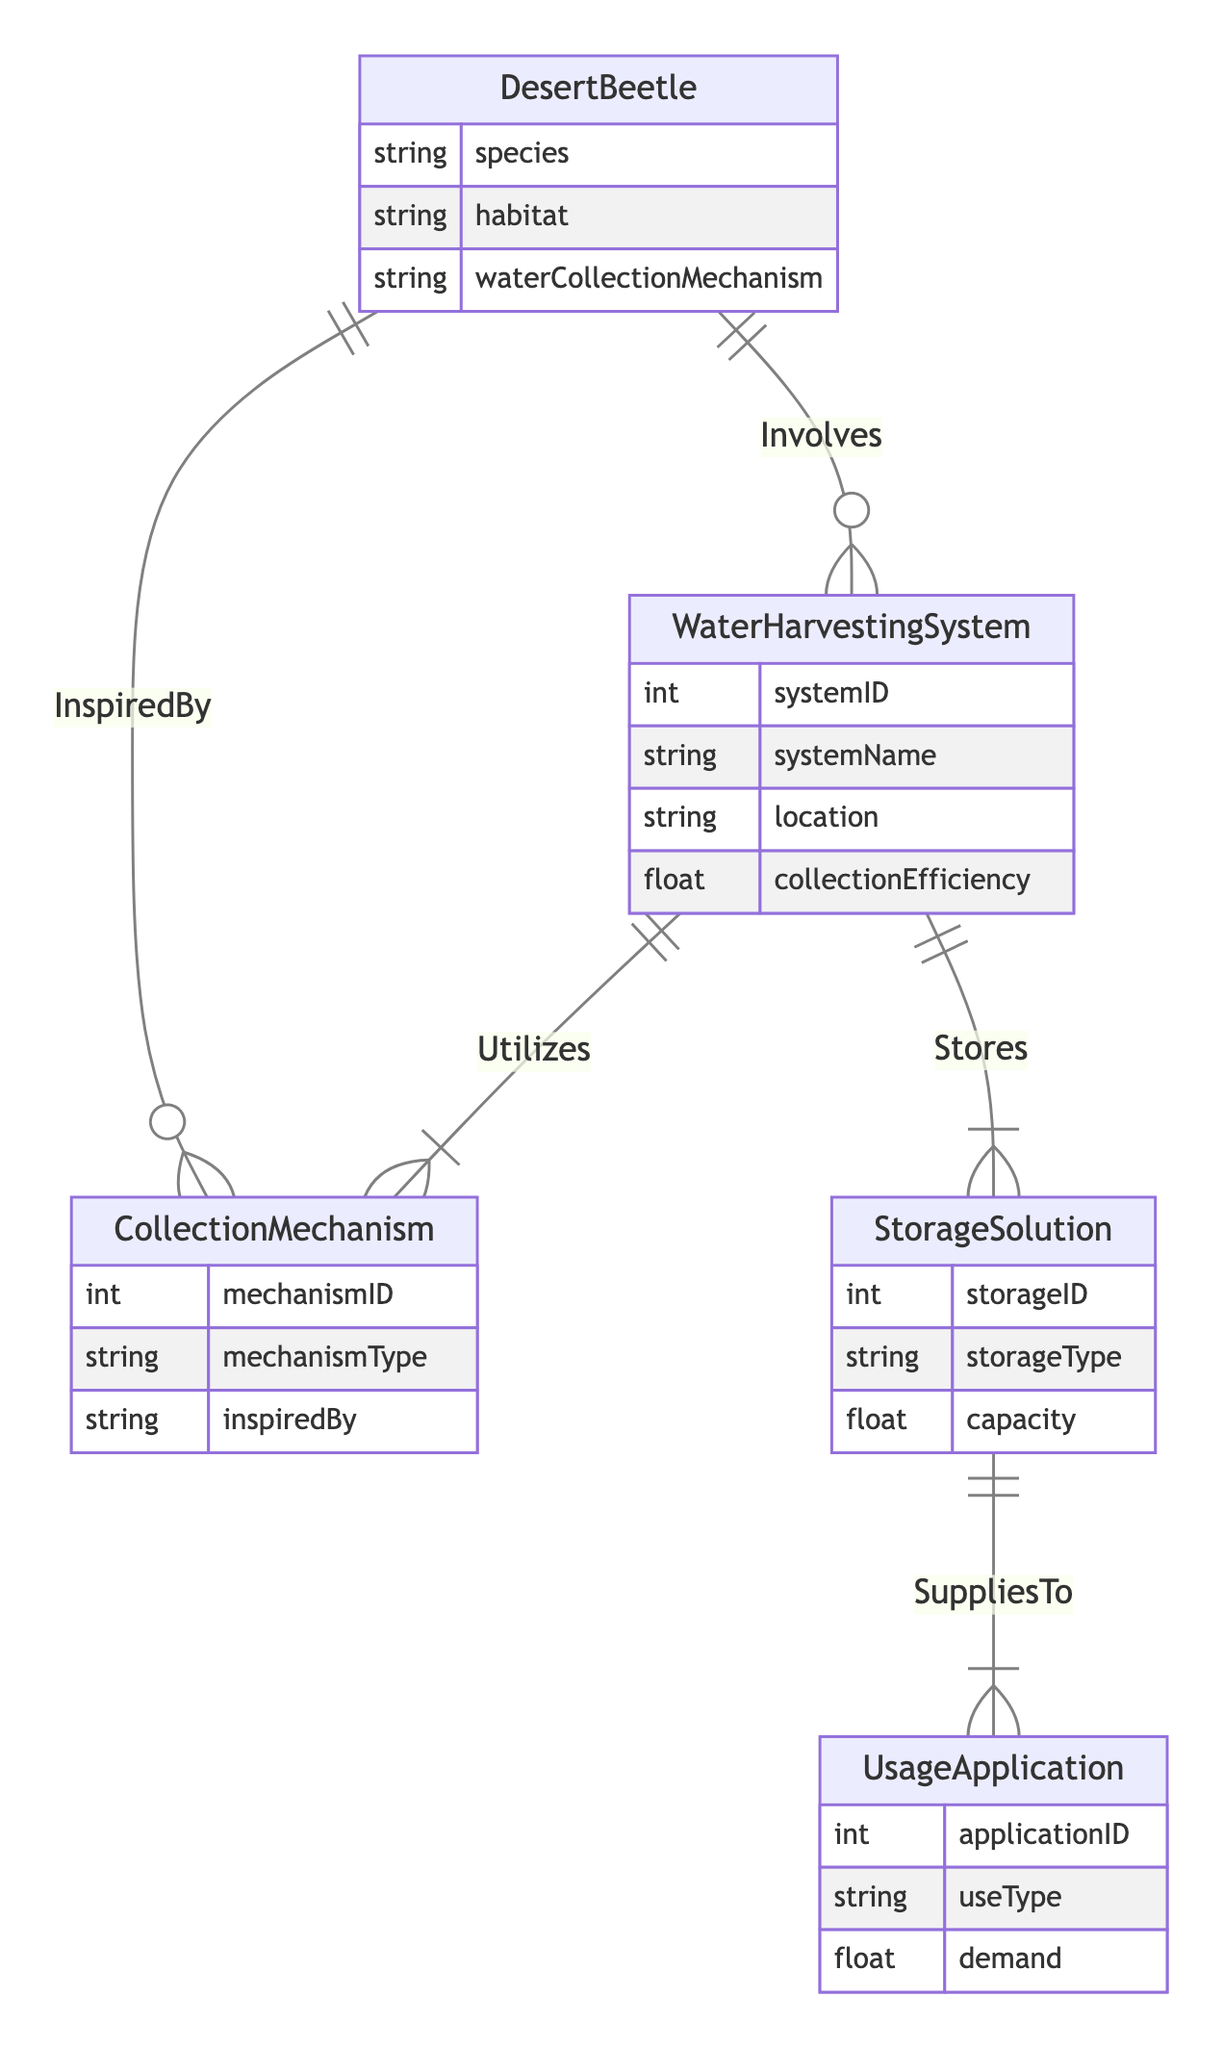What is the main purpose of the "Involves" relationship? The "Involves" relationship shows that the Desert Beetle entity is connected to the Water Harvesting System, indicating that aspects of the beetle are incorporated into the design or function of the water harvesting system.
Answer: Connects beetle to harvesting system How many primary entities are represented in this diagram? The diagram shows five primary entities: Desert Beetle, Water Harvesting System, Collection Mechanism, Storage Solution, and Usage Application. Counting these gives a total of five entities.
Answer: Five What type of data does the Storage Solution entity include? The Storage Solution entity includes three attributes: storage ID, storage type, and capacity, containing information relevant to storage systems.
Answer: Storage ID, storage type, capacity Which entity has a direct relationship with both Collection Mechanism and Storage Solution? The Water Harvesting System entity has relationships with both the Collection Mechanism (utilizes) and Storage Solution (stores) entities, indicating its role as a central element.
Answer: Water Harvesting System What does the "SuppliesTo" relationship signify in this context? The "SuppliesTo" relationship indicates that the Storage Solution entity provides water to the Usage Application entity, showing how storage affects application usage.
Answer: Water storage provides to applications How many types of relationships are depicted in the diagram? There are a total of five distinct types of relationships represented: Involves, Utilizes, Stores, SuppliesTo, and InspiredBy.
Answer: Five Which entity is inspired by the Desert Beetle entity? The Collection Mechanism entity is directly inspired by the Desert Beetle, indicating that its design or functionality is modeled after aspects of the beetle.
Answer: Collection Mechanism What is the relationship between Water Harvesting System and Collection Mechanism? The Water Harvesting System utilizes the Collection Mechanism, demonstrating that the harvesting systems depend on these mechanisms for water collection.
Answer: Utilizes Which attributes belong to the Desert Beetle entity? The Desert Beetle entity includes three attributes: species, habitat, and water collection mechanism, detailing essential information about the beetle.
Answer: Species, habitat, water collection mechanism 